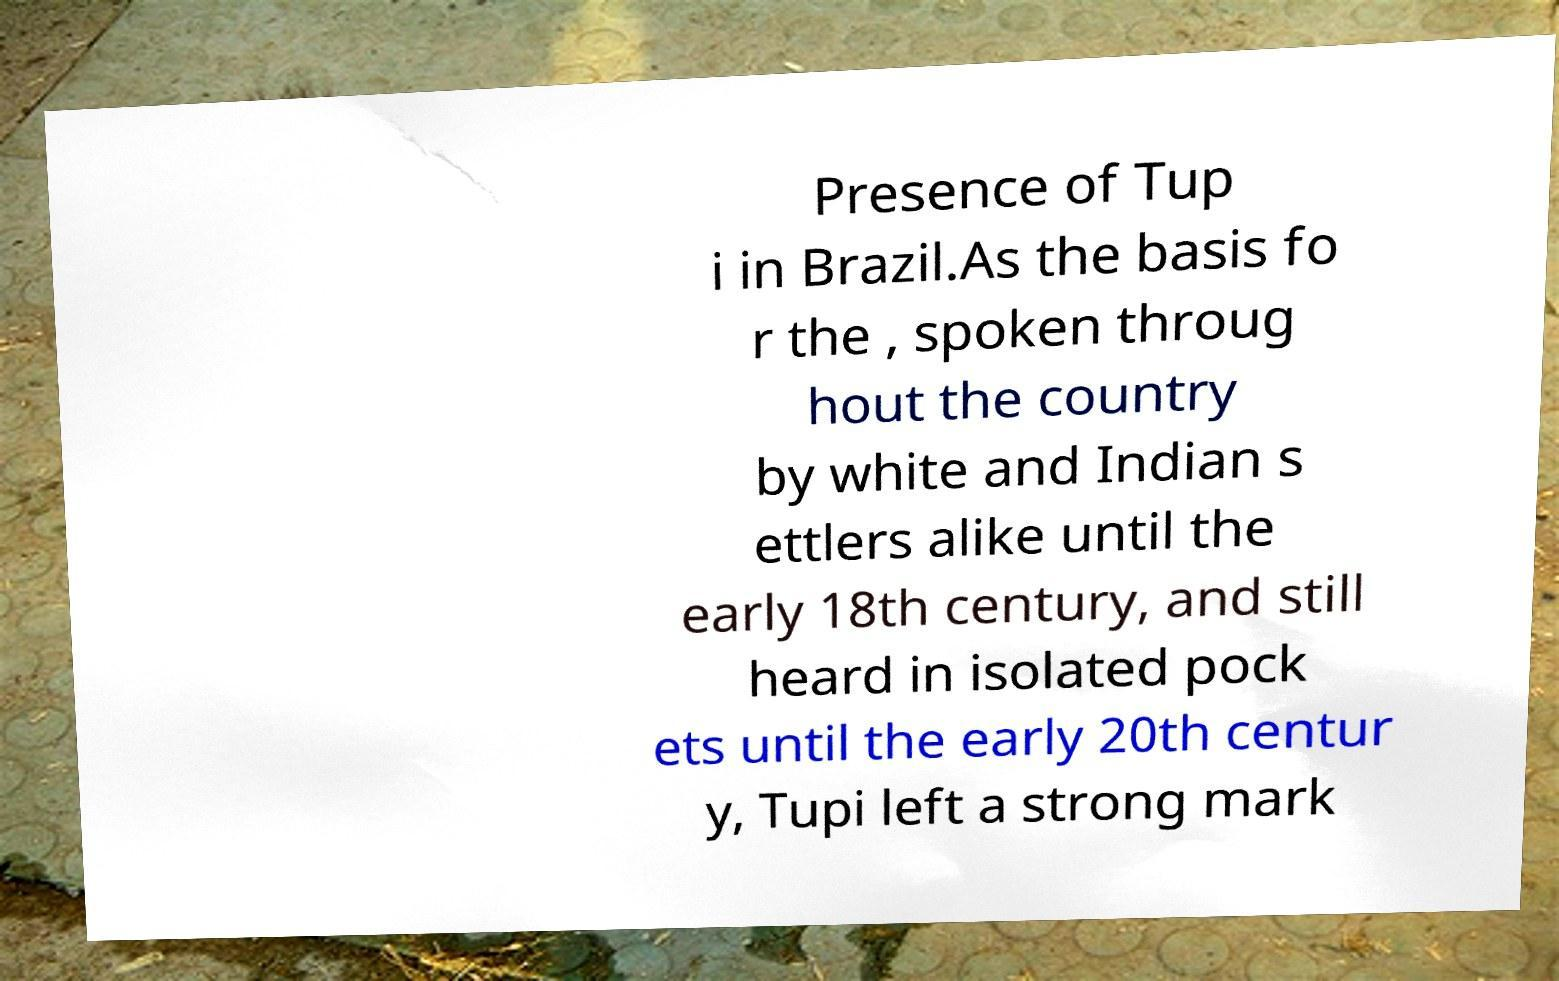What messages or text are displayed in this image? I need them in a readable, typed format. Presence of Tup i in Brazil.As the basis fo r the , spoken throug hout the country by white and Indian s ettlers alike until the early 18th century, and still heard in isolated pock ets until the early 20th centur y, Tupi left a strong mark 